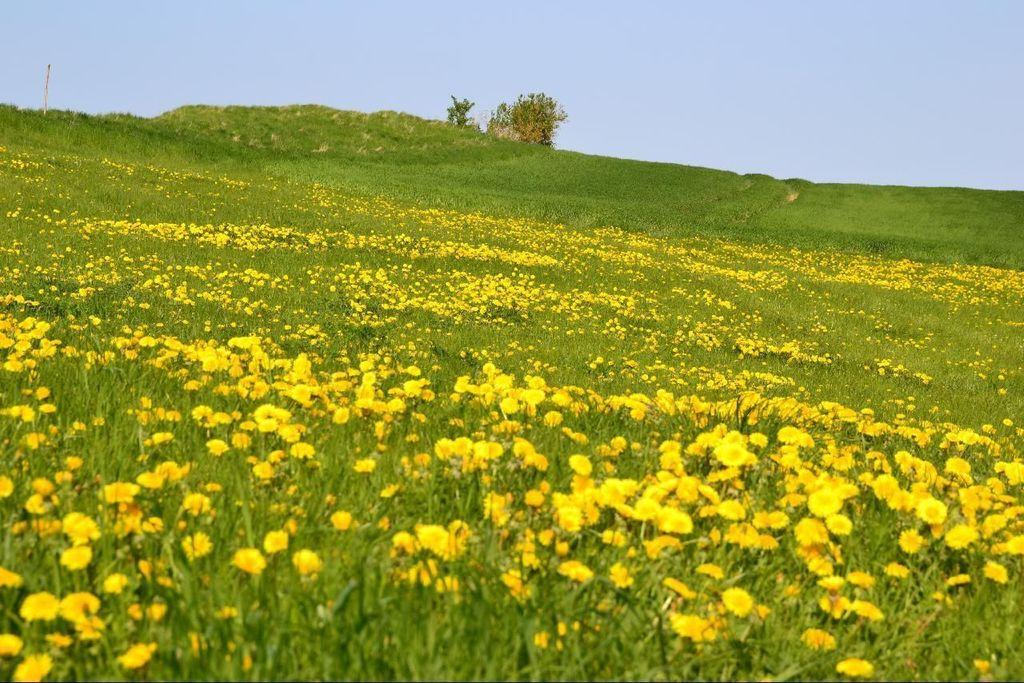What type of flowers can be seen in the image? There is a field of yellow color flowers in the image. What color is the sky in the image? The sky is blue in the image. Can you hear the governor speaking in the image? There is no audio or indication of a governor speaking in the image; it is a visual representation of a field of yellow flowers and a blue sky. 